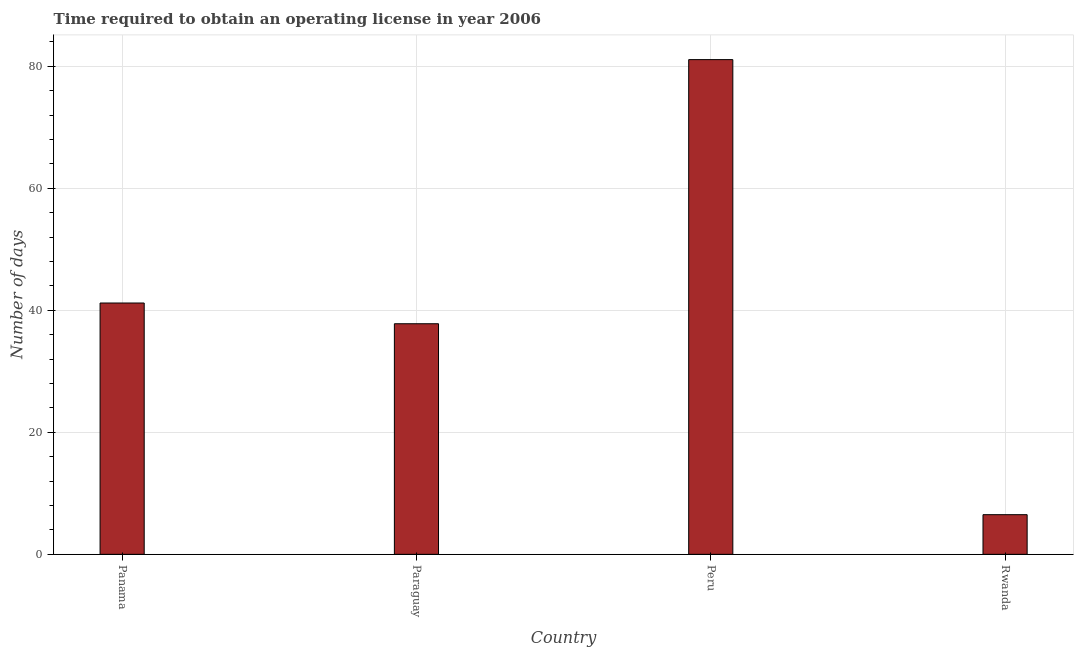Does the graph contain grids?
Your response must be concise. Yes. What is the title of the graph?
Keep it short and to the point. Time required to obtain an operating license in year 2006. What is the label or title of the Y-axis?
Make the answer very short. Number of days. What is the number of days to obtain operating license in Paraguay?
Provide a short and direct response. 37.8. Across all countries, what is the maximum number of days to obtain operating license?
Offer a terse response. 81.1. Across all countries, what is the minimum number of days to obtain operating license?
Your answer should be very brief. 6.5. In which country was the number of days to obtain operating license maximum?
Your answer should be compact. Peru. In which country was the number of days to obtain operating license minimum?
Keep it short and to the point. Rwanda. What is the sum of the number of days to obtain operating license?
Keep it short and to the point. 166.6. What is the difference between the number of days to obtain operating license in Panama and Paraguay?
Your response must be concise. 3.4. What is the average number of days to obtain operating license per country?
Provide a short and direct response. 41.65. What is the median number of days to obtain operating license?
Keep it short and to the point. 39.5. What is the ratio of the number of days to obtain operating license in Panama to that in Peru?
Provide a short and direct response. 0.51. Is the difference between the number of days to obtain operating license in Panama and Paraguay greater than the difference between any two countries?
Offer a very short reply. No. What is the difference between the highest and the second highest number of days to obtain operating license?
Your answer should be very brief. 39.9. What is the difference between the highest and the lowest number of days to obtain operating license?
Offer a very short reply. 74.6. In how many countries, is the number of days to obtain operating license greater than the average number of days to obtain operating license taken over all countries?
Make the answer very short. 1. How many bars are there?
Keep it short and to the point. 4. Are all the bars in the graph horizontal?
Keep it short and to the point. No. What is the difference between two consecutive major ticks on the Y-axis?
Your response must be concise. 20. Are the values on the major ticks of Y-axis written in scientific E-notation?
Offer a terse response. No. What is the Number of days in Panama?
Your answer should be very brief. 41.2. What is the Number of days in Paraguay?
Ensure brevity in your answer.  37.8. What is the Number of days in Peru?
Provide a succinct answer. 81.1. What is the difference between the Number of days in Panama and Paraguay?
Your response must be concise. 3.4. What is the difference between the Number of days in Panama and Peru?
Your answer should be very brief. -39.9. What is the difference between the Number of days in Panama and Rwanda?
Ensure brevity in your answer.  34.7. What is the difference between the Number of days in Paraguay and Peru?
Your answer should be very brief. -43.3. What is the difference between the Number of days in Paraguay and Rwanda?
Offer a very short reply. 31.3. What is the difference between the Number of days in Peru and Rwanda?
Offer a terse response. 74.6. What is the ratio of the Number of days in Panama to that in Paraguay?
Offer a terse response. 1.09. What is the ratio of the Number of days in Panama to that in Peru?
Your answer should be compact. 0.51. What is the ratio of the Number of days in Panama to that in Rwanda?
Give a very brief answer. 6.34. What is the ratio of the Number of days in Paraguay to that in Peru?
Provide a succinct answer. 0.47. What is the ratio of the Number of days in Paraguay to that in Rwanda?
Offer a very short reply. 5.82. What is the ratio of the Number of days in Peru to that in Rwanda?
Provide a short and direct response. 12.48. 